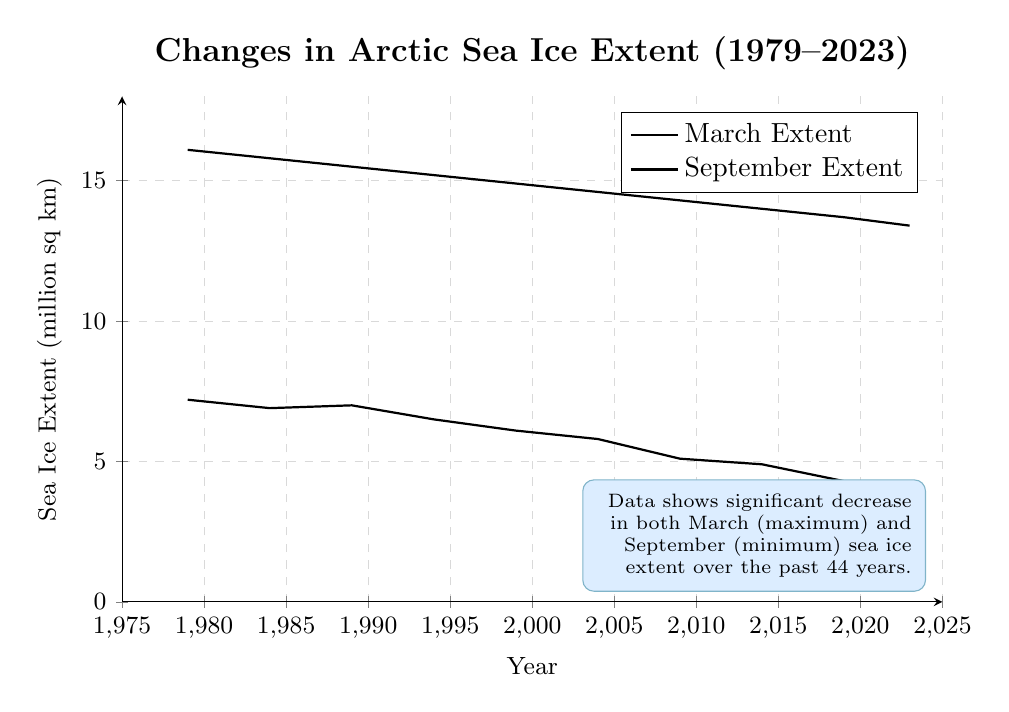What is the general trend of the March sea ice extent from 1979 to 2023? Observing the data points for March, it shows a steady decline over time. By comparing the values from 1979 (16.1 million sq km) and 2023 (13.4 million sq km), we can see a decrease.
Answer: Decreasing Which year shows the smallest September sea ice extent? By looking at the September values, 2023 has the smallest extent at 3.8 million sq km.
Answer: 2023 What is the difference between the March and September sea ice extents in 2023? The March extent in 2023 is 13.4 million sq km, and the September extent is 3.8 million sq km. Subtracting these gives 13.4 - 3.8 = 9.6 million sq km.
Answer: 9.6 million sq km How much did the September sea ice extent decrease from 1979 to 2023? In 1979, the September extent was 7.2 million sq km and in 2023, it was 3.8 million sq km. The decrease is 7.2 - 3.8 = 3.4 million sq km.
Answer: 3.4 million sq km When did the March sea ice extent first fall below 15 million sq km? The March sea ice extent first falls below 15 million sq km in 1994, where the extent is 15.2 million sq km. The next value in 1999 is 14.9 million sq km, which is below 15 million sq km.
Answer: 1999 How much did the March sea ice extent decrease on average per decade from 1979 to 2023? To find the average decrease per decade: first, calculate the total decrease: 16.1 - 13.4 = 2.7 million sq km from 1979 to 2023 (44 years). Therefore, in 44 years, the average per decade is (2.7 / 44) * 10 = 0.61 million sq km.
Answer: 0.61 million sq km Between which two consecutive years was the September sea ice extent decline the greatest? Comparing the differences between each consecutive pair for September: (1979-1984: 0.3), (1984-1989: -0.1), (1989-1994: 0.5), (1994-1999: 0.4), (1999-2004: 0.3), (2004-2009: 0.7), (2009-2014: 0.2), (2014-2019: 0.6), (2019-2023: 0.5). The greatest decline is between 2004 and 2009 (0.7 million sq km).
Answer: 2004 to 2009 What is the average sea ice extent in March over the whole period? Sum all March values: 16.1 + 15.8 + 15.5 + 15.2 + 14.9 + 14.6 + 14.3 + 14.0 + 13.7 + 13.4 = 147.5. Then divide by the number of years: 147.5 / 10 = 14.75 million sq km.
Answer: 14.75 million sq km Rate the decline in September sea ice extent in terms of percentage from 1979 to 2023. Calculate the percentage decline: (7.2-3.8) / 7.2 * 100 = 47.22%.
Answer: 47.22% Which month, March or September, shows a more significant decline over the period? Compare the overall declines: March (16.1 million sq km in 1979 to 13.4 million sq km in 2023, a decrease of 2.7 million sq km) and September (7.2 million sq km in 1979 to 3.8 million sq km in 2023, a decrease of 3.4 million sq km). The more significant decline is in September.
Answer: September 